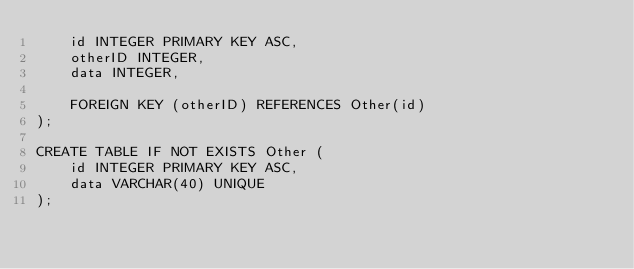Convert code to text. <code><loc_0><loc_0><loc_500><loc_500><_SQL_>	id INTEGER PRIMARY KEY ASC,
	otherID INTEGER,
	data INTEGER,

	FOREIGN KEY (otherID) REFERENCES Other(id)
);

CREATE TABLE IF NOT EXISTS Other (
	id INTEGER PRIMARY KEY ASC,
	data VARCHAR(40) UNIQUE
);
</code> 